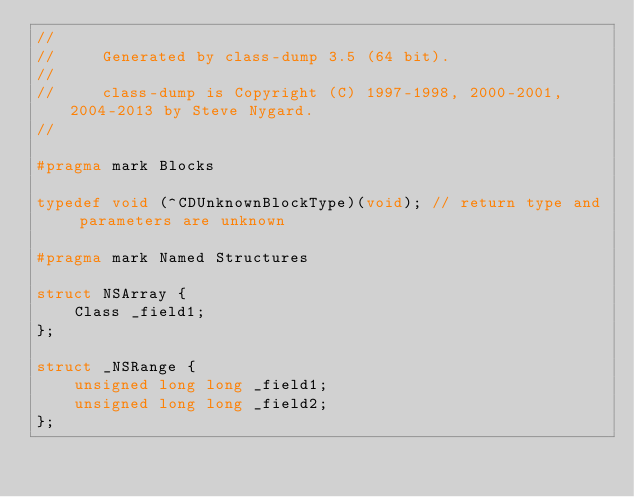Convert code to text. <code><loc_0><loc_0><loc_500><loc_500><_C_>//
//     Generated by class-dump 3.5 (64 bit).
//
//     class-dump is Copyright (C) 1997-1998, 2000-2001, 2004-2013 by Steve Nygard.
//

#pragma mark Blocks

typedef void (^CDUnknownBlockType)(void); // return type and parameters are unknown

#pragma mark Named Structures

struct NSArray {
    Class _field1;
};

struct _NSRange {
    unsigned long long _field1;
    unsigned long long _field2;
};

</code> 